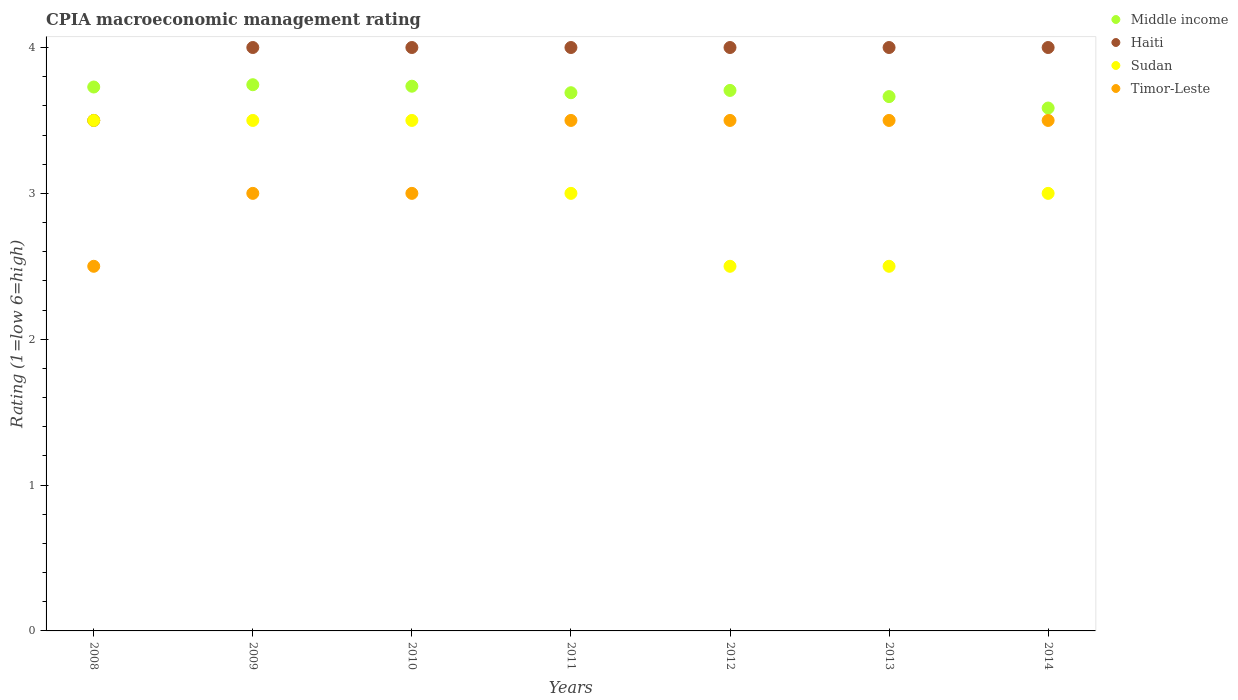How many different coloured dotlines are there?
Your answer should be very brief. 4. Across all years, what is the minimum CPIA rating in Middle income?
Keep it short and to the point. 3.59. In which year was the CPIA rating in Middle income minimum?
Your response must be concise. 2014. What is the total CPIA rating in Middle income in the graph?
Ensure brevity in your answer.  25.85. What is the difference between the CPIA rating in Sudan in 2013 and the CPIA rating in Timor-Leste in 2008?
Give a very brief answer. 0. What is the average CPIA rating in Haiti per year?
Your response must be concise. 3.93. In the year 2011, what is the difference between the CPIA rating in Middle income and CPIA rating in Haiti?
Your answer should be compact. -0.31. In how many years, is the CPIA rating in Sudan greater than 3.6?
Offer a terse response. 0. Is the CPIA rating in Sudan in 2009 less than that in 2010?
Your answer should be compact. No. What is the difference between the highest and the second highest CPIA rating in Sudan?
Offer a very short reply. 0. What is the difference between the highest and the lowest CPIA rating in Middle income?
Your answer should be very brief. 0.16. Is it the case that in every year, the sum of the CPIA rating in Haiti and CPIA rating in Timor-Leste  is greater than the sum of CPIA rating in Sudan and CPIA rating in Middle income?
Keep it short and to the point. No. Is it the case that in every year, the sum of the CPIA rating in Middle income and CPIA rating in Haiti  is greater than the CPIA rating in Timor-Leste?
Offer a terse response. Yes. Does the CPIA rating in Haiti monotonically increase over the years?
Provide a short and direct response. No. Is the CPIA rating in Timor-Leste strictly greater than the CPIA rating in Sudan over the years?
Keep it short and to the point. No. Is the CPIA rating in Sudan strictly less than the CPIA rating in Timor-Leste over the years?
Offer a terse response. No. How many dotlines are there?
Your answer should be very brief. 4. Are the values on the major ticks of Y-axis written in scientific E-notation?
Give a very brief answer. No. What is the title of the graph?
Your answer should be very brief. CPIA macroeconomic management rating. What is the label or title of the X-axis?
Provide a short and direct response. Years. What is the Rating (1=low 6=high) in Middle income in 2008?
Keep it short and to the point. 3.73. What is the Rating (1=low 6=high) of Haiti in 2008?
Give a very brief answer. 3.5. What is the Rating (1=low 6=high) of Sudan in 2008?
Keep it short and to the point. 3.5. What is the Rating (1=low 6=high) of Middle income in 2009?
Your answer should be very brief. 3.74. What is the Rating (1=low 6=high) in Haiti in 2009?
Your answer should be compact. 4. What is the Rating (1=low 6=high) of Timor-Leste in 2009?
Offer a very short reply. 3. What is the Rating (1=low 6=high) in Middle income in 2010?
Offer a terse response. 3.73. What is the Rating (1=low 6=high) of Middle income in 2011?
Keep it short and to the point. 3.69. What is the Rating (1=low 6=high) in Timor-Leste in 2011?
Make the answer very short. 3.5. What is the Rating (1=low 6=high) in Middle income in 2012?
Give a very brief answer. 3.71. What is the Rating (1=low 6=high) of Haiti in 2012?
Ensure brevity in your answer.  4. What is the Rating (1=low 6=high) of Sudan in 2012?
Keep it short and to the point. 2.5. What is the Rating (1=low 6=high) in Middle income in 2013?
Ensure brevity in your answer.  3.66. What is the Rating (1=low 6=high) in Haiti in 2013?
Offer a very short reply. 4. What is the Rating (1=low 6=high) in Sudan in 2013?
Provide a succinct answer. 2.5. What is the Rating (1=low 6=high) in Timor-Leste in 2013?
Give a very brief answer. 3.5. What is the Rating (1=low 6=high) of Middle income in 2014?
Provide a succinct answer. 3.59. What is the Rating (1=low 6=high) in Haiti in 2014?
Offer a terse response. 4. What is the Rating (1=low 6=high) of Sudan in 2014?
Offer a terse response. 3. What is the Rating (1=low 6=high) in Timor-Leste in 2014?
Your answer should be compact. 3.5. Across all years, what is the maximum Rating (1=low 6=high) in Middle income?
Give a very brief answer. 3.74. Across all years, what is the minimum Rating (1=low 6=high) in Middle income?
Offer a very short reply. 3.59. Across all years, what is the minimum Rating (1=low 6=high) of Haiti?
Offer a terse response. 3.5. Across all years, what is the minimum Rating (1=low 6=high) in Sudan?
Provide a short and direct response. 2.5. What is the total Rating (1=low 6=high) in Middle income in the graph?
Offer a terse response. 25.85. What is the total Rating (1=low 6=high) in Sudan in the graph?
Make the answer very short. 21.5. What is the total Rating (1=low 6=high) of Timor-Leste in the graph?
Make the answer very short. 22.5. What is the difference between the Rating (1=low 6=high) in Middle income in 2008 and that in 2009?
Give a very brief answer. -0.02. What is the difference between the Rating (1=low 6=high) in Sudan in 2008 and that in 2009?
Your answer should be compact. 0. What is the difference between the Rating (1=low 6=high) of Timor-Leste in 2008 and that in 2009?
Ensure brevity in your answer.  -0.5. What is the difference between the Rating (1=low 6=high) of Middle income in 2008 and that in 2010?
Keep it short and to the point. -0.01. What is the difference between the Rating (1=low 6=high) of Sudan in 2008 and that in 2010?
Offer a very short reply. 0. What is the difference between the Rating (1=low 6=high) of Timor-Leste in 2008 and that in 2010?
Give a very brief answer. -0.5. What is the difference between the Rating (1=low 6=high) of Middle income in 2008 and that in 2011?
Keep it short and to the point. 0.04. What is the difference between the Rating (1=low 6=high) in Haiti in 2008 and that in 2011?
Give a very brief answer. -0.5. What is the difference between the Rating (1=low 6=high) in Sudan in 2008 and that in 2011?
Make the answer very short. 0.5. What is the difference between the Rating (1=low 6=high) of Middle income in 2008 and that in 2012?
Give a very brief answer. 0.02. What is the difference between the Rating (1=low 6=high) of Haiti in 2008 and that in 2012?
Provide a short and direct response. -0.5. What is the difference between the Rating (1=low 6=high) of Timor-Leste in 2008 and that in 2012?
Provide a succinct answer. -1. What is the difference between the Rating (1=low 6=high) of Middle income in 2008 and that in 2013?
Offer a very short reply. 0.07. What is the difference between the Rating (1=low 6=high) in Middle income in 2008 and that in 2014?
Provide a succinct answer. 0.14. What is the difference between the Rating (1=low 6=high) of Timor-Leste in 2008 and that in 2014?
Provide a short and direct response. -1. What is the difference between the Rating (1=low 6=high) in Middle income in 2009 and that in 2010?
Keep it short and to the point. 0.01. What is the difference between the Rating (1=low 6=high) in Sudan in 2009 and that in 2010?
Offer a very short reply. 0. What is the difference between the Rating (1=low 6=high) in Middle income in 2009 and that in 2011?
Your answer should be compact. 0.05. What is the difference between the Rating (1=low 6=high) of Middle income in 2009 and that in 2012?
Your answer should be compact. 0.04. What is the difference between the Rating (1=low 6=high) in Middle income in 2009 and that in 2013?
Make the answer very short. 0.08. What is the difference between the Rating (1=low 6=high) in Haiti in 2009 and that in 2013?
Give a very brief answer. 0. What is the difference between the Rating (1=low 6=high) of Timor-Leste in 2009 and that in 2013?
Make the answer very short. -0.5. What is the difference between the Rating (1=low 6=high) of Middle income in 2009 and that in 2014?
Your response must be concise. 0.16. What is the difference between the Rating (1=low 6=high) in Haiti in 2009 and that in 2014?
Make the answer very short. 0. What is the difference between the Rating (1=low 6=high) of Sudan in 2009 and that in 2014?
Provide a short and direct response. 0.5. What is the difference between the Rating (1=low 6=high) in Timor-Leste in 2009 and that in 2014?
Your answer should be compact. -0.5. What is the difference between the Rating (1=low 6=high) in Middle income in 2010 and that in 2011?
Your answer should be compact. 0.04. What is the difference between the Rating (1=low 6=high) in Timor-Leste in 2010 and that in 2011?
Provide a short and direct response. -0.5. What is the difference between the Rating (1=low 6=high) of Middle income in 2010 and that in 2012?
Give a very brief answer. 0.03. What is the difference between the Rating (1=low 6=high) of Haiti in 2010 and that in 2012?
Offer a terse response. 0. What is the difference between the Rating (1=low 6=high) of Sudan in 2010 and that in 2012?
Provide a succinct answer. 1. What is the difference between the Rating (1=low 6=high) in Timor-Leste in 2010 and that in 2012?
Provide a short and direct response. -0.5. What is the difference between the Rating (1=low 6=high) of Middle income in 2010 and that in 2013?
Give a very brief answer. 0.07. What is the difference between the Rating (1=low 6=high) in Sudan in 2010 and that in 2013?
Provide a short and direct response. 1. What is the difference between the Rating (1=low 6=high) of Middle income in 2010 and that in 2014?
Make the answer very short. 0.15. What is the difference between the Rating (1=low 6=high) in Sudan in 2010 and that in 2014?
Offer a terse response. 0.5. What is the difference between the Rating (1=low 6=high) of Timor-Leste in 2010 and that in 2014?
Offer a very short reply. -0.5. What is the difference between the Rating (1=low 6=high) of Middle income in 2011 and that in 2012?
Your answer should be very brief. -0.02. What is the difference between the Rating (1=low 6=high) of Haiti in 2011 and that in 2012?
Make the answer very short. 0. What is the difference between the Rating (1=low 6=high) in Middle income in 2011 and that in 2013?
Keep it short and to the point. 0.03. What is the difference between the Rating (1=low 6=high) in Sudan in 2011 and that in 2013?
Keep it short and to the point. 0.5. What is the difference between the Rating (1=low 6=high) of Middle income in 2011 and that in 2014?
Offer a terse response. 0.1. What is the difference between the Rating (1=low 6=high) of Haiti in 2011 and that in 2014?
Your answer should be compact. 0. What is the difference between the Rating (1=low 6=high) in Sudan in 2011 and that in 2014?
Give a very brief answer. 0. What is the difference between the Rating (1=low 6=high) in Timor-Leste in 2011 and that in 2014?
Provide a succinct answer. 0. What is the difference between the Rating (1=low 6=high) in Middle income in 2012 and that in 2013?
Give a very brief answer. 0.04. What is the difference between the Rating (1=low 6=high) of Sudan in 2012 and that in 2013?
Offer a very short reply. 0. What is the difference between the Rating (1=low 6=high) in Timor-Leste in 2012 and that in 2013?
Offer a terse response. 0. What is the difference between the Rating (1=low 6=high) in Middle income in 2012 and that in 2014?
Give a very brief answer. 0.12. What is the difference between the Rating (1=low 6=high) of Haiti in 2012 and that in 2014?
Keep it short and to the point. 0. What is the difference between the Rating (1=low 6=high) in Sudan in 2012 and that in 2014?
Keep it short and to the point. -0.5. What is the difference between the Rating (1=low 6=high) of Middle income in 2013 and that in 2014?
Your answer should be compact. 0.08. What is the difference between the Rating (1=low 6=high) in Haiti in 2013 and that in 2014?
Your answer should be very brief. 0. What is the difference between the Rating (1=low 6=high) in Sudan in 2013 and that in 2014?
Offer a very short reply. -0.5. What is the difference between the Rating (1=low 6=high) in Timor-Leste in 2013 and that in 2014?
Your answer should be compact. 0. What is the difference between the Rating (1=low 6=high) of Middle income in 2008 and the Rating (1=low 6=high) of Haiti in 2009?
Provide a short and direct response. -0.27. What is the difference between the Rating (1=low 6=high) in Middle income in 2008 and the Rating (1=low 6=high) in Sudan in 2009?
Your response must be concise. 0.23. What is the difference between the Rating (1=low 6=high) of Middle income in 2008 and the Rating (1=low 6=high) of Timor-Leste in 2009?
Ensure brevity in your answer.  0.73. What is the difference between the Rating (1=low 6=high) in Haiti in 2008 and the Rating (1=low 6=high) in Sudan in 2009?
Offer a terse response. 0. What is the difference between the Rating (1=low 6=high) in Haiti in 2008 and the Rating (1=low 6=high) in Timor-Leste in 2009?
Keep it short and to the point. 0.5. What is the difference between the Rating (1=low 6=high) in Sudan in 2008 and the Rating (1=low 6=high) in Timor-Leste in 2009?
Make the answer very short. 0.5. What is the difference between the Rating (1=low 6=high) in Middle income in 2008 and the Rating (1=low 6=high) in Haiti in 2010?
Ensure brevity in your answer.  -0.27. What is the difference between the Rating (1=low 6=high) in Middle income in 2008 and the Rating (1=low 6=high) in Sudan in 2010?
Keep it short and to the point. 0.23. What is the difference between the Rating (1=low 6=high) in Middle income in 2008 and the Rating (1=low 6=high) in Timor-Leste in 2010?
Offer a very short reply. 0.73. What is the difference between the Rating (1=low 6=high) in Haiti in 2008 and the Rating (1=low 6=high) in Timor-Leste in 2010?
Make the answer very short. 0.5. What is the difference between the Rating (1=low 6=high) of Middle income in 2008 and the Rating (1=low 6=high) of Haiti in 2011?
Offer a very short reply. -0.27. What is the difference between the Rating (1=low 6=high) of Middle income in 2008 and the Rating (1=low 6=high) of Sudan in 2011?
Make the answer very short. 0.73. What is the difference between the Rating (1=low 6=high) in Middle income in 2008 and the Rating (1=low 6=high) in Timor-Leste in 2011?
Provide a short and direct response. 0.23. What is the difference between the Rating (1=low 6=high) of Haiti in 2008 and the Rating (1=low 6=high) of Timor-Leste in 2011?
Offer a very short reply. 0. What is the difference between the Rating (1=low 6=high) in Sudan in 2008 and the Rating (1=low 6=high) in Timor-Leste in 2011?
Offer a terse response. 0. What is the difference between the Rating (1=low 6=high) in Middle income in 2008 and the Rating (1=low 6=high) in Haiti in 2012?
Your answer should be very brief. -0.27. What is the difference between the Rating (1=low 6=high) in Middle income in 2008 and the Rating (1=low 6=high) in Sudan in 2012?
Give a very brief answer. 1.23. What is the difference between the Rating (1=low 6=high) of Middle income in 2008 and the Rating (1=low 6=high) of Timor-Leste in 2012?
Your answer should be very brief. 0.23. What is the difference between the Rating (1=low 6=high) in Haiti in 2008 and the Rating (1=low 6=high) in Sudan in 2012?
Provide a succinct answer. 1. What is the difference between the Rating (1=low 6=high) in Sudan in 2008 and the Rating (1=low 6=high) in Timor-Leste in 2012?
Make the answer very short. 0. What is the difference between the Rating (1=low 6=high) of Middle income in 2008 and the Rating (1=low 6=high) of Haiti in 2013?
Make the answer very short. -0.27. What is the difference between the Rating (1=low 6=high) in Middle income in 2008 and the Rating (1=low 6=high) in Sudan in 2013?
Your response must be concise. 1.23. What is the difference between the Rating (1=low 6=high) in Middle income in 2008 and the Rating (1=low 6=high) in Timor-Leste in 2013?
Offer a terse response. 0.23. What is the difference between the Rating (1=low 6=high) of Haiti in 2008 and the Rating (1=low 6=high) of Sudan in 2013?
Provide a short and direct response. 1. What is the difference between the Rating (1=low 6=high) in Haiti in 2008 and the Rating (1=low 6=high) in Timor-Leste in 2013?
Provide a succinct answer. 0. What is the difference between the Rating (1=low 6=high) of Middle income in 2008 and the Rating (1=low 6=high) of Haiti in 2014?
Ensure brevity in your answer.  -0.27. What is the difference between the Rating (1=low 6=high) of Middle income in 2008 and the Rating (1=low 6=high) of Sudan in 2014?
Your response must be concise. 0.73. What is the difference between the Rating (1=low 6=high) in Middle income in 2008 and the Rating (1=low 6=high) in Timor-Leste in 2014?
Offer a terse response. 0.23. What is the difference between the Rating (1=low 6=high) in Haiti in 2008 and the Rating (1=low 6=high) in Sudan in 2014?
Provide a short and direct response. 0.5. What is the difference between the Rating (1=low 6=high) in Haiti in 2008 and the Rating (1=low 6=high) in Timor-Leste in 2014?
Give a very brief answer. 0. What is the difference between the Rating (1=low 6=high) in Sudan in 2008 and the Rating (1=low 6=high) in Timor-Leste in 2014?
Keep it short and to the point. 0. What is the difference between the Rating (1=low 6=high) in Middle income in 2009 and the Rating (1=low 6=high) in Haiti in 2010?
Make the answer very short. -0.26. What is the difference between the Rating (1=low 6=high) in Middle income in 2009 and the Rating (1=low 6=high) in Sudan in 2010?
Make the answer very short. 0.24. What is the difference between the Rating (1=low 6=high) in Middle income in 2009 and the Rating (1=low 6=high) in Timor-Leste in 2010?
Offer a terse response. 0.74. What is the difference between the Rating (1=low 6=high) in Haiti in 2009 and the Rating (1=low 6=high) in Sudan in 2010?
Ensure brevity in your answer.  0.5. What is the difference between the Rating (1=low 6=high) of Haiti in 2009 and the Rating (1=low 6=high) of Timor-Leste in 2010?
Provide a short and direct response. 1. What is the difference between the Rating (1=low 6=high) in Sudan in 2009 and the Rating (1=low 6=high) in Timor-Leste in 2010?
Provide a succinct answer. 0.5. What is the difference between the Rating (1=low 6=high) of Middle income in 2009 and the Rating (1=low 6=high) of Haiti in 2011?
Make the answer very short. -0.26. What is the difference between the Rating (1=low 6=high) of Middle income in 2009 and the Rating (1=low 6=high) of Sudan in 2011?
Ensure brevity in your answer.  0.74. What is the difference between the Rating (1=low 6=high) of Middle income in 2009 and the Rating (1=low 6=high) of Timor-Leste in 2011?
Provide a succinct answer. 0.24. What is the difference between the Rating (1=low 6=high) of Middle income in 2009 and the Rating (1=low 6=high) of Haiti in 2012?
Provide a succinct answer. -0.26. What is the difference between the Rating (1=low 6=high) of Middle income in 2009 and the Rating (1=low 6=high) of Sudan in 2012?
Ensure brevity in your answer.  1.24. What is the difference between the Rating (1=low 6=high) of Middle income in 2009 and the Rating (1=low 6=high) of Timor-Leste in 2012?
Make the answer very short. 0.24. What is the difference between the Rating (1=low 6=high) of Middle income in 2009 and the Rating (1=low 6=high) of Haiti in 2013?
Offer a terse response. -0.26. What is the difference between the Rating (1=low 6=high) of Middle income in 2009 and the Rating (1=low 6=high) of Sudan in 2013?
Ensure brevity in your answer.  1.24. What is the difference between the Rating (1=low 6=high) in Middle income in 2009 and the Rating (1=low 6=high) in Timor-Leste in 2013?
Provide a short and direct response. 0.24. What is the difference between the Rating (1=low 6=high) in Haiti in 2009 and the Rating (1=low 6=high) in Timor-Leste in 2013?
Ensure brevity in your answer.  0.5. What is the difference between the Rating (1=low 6=high) of Sudan in 2009 and the Rating (1=low 6=high) of Timor-Leste in 2013?
Your answer should be very brief. 0. What is the difference between the Rating (1=low 6=high) of Middle income in 2009 and the Rating (1=low 6=high) of Haiti in 2014?
Keep it short and to the point. -0.26. What is the difference between the Rating (1=low 6=high) of Middle income in 2009 and the Rating (1=low 6=high) of Sudan in 2014?
Keep it short and to the point. 0.74. What is the difference between the Rating (1=low 6=high) in Middle income in 2009 and the Rating (1=low 6=high) in Timor-Leste in 2014?
Your response must be concise. 0.24. What is the difference between the Rating (1=low 6=high) of Haiti in 2009 and the Rating (1=low 6=high) of Sudan in 2014?
Offer a very short reply. 1. What is the difference between the Rating (1=low 6=high) in Sudan in 2009 and the Rating (1=low 6=high) in Timor-Leste in 2014?
Offer a terse response. 0. What is the difference between the Rating (1=low 6=high) in Middle income in 2010 and the Rating (1=low 6=high) in Haiti in 2011?
Provide a short and direct response. -0.27. What is the difference between the Rating (1=low 6=high) of Middle income in 2010 and the Rating (1=low 6=high) of Sudan in 2011?
Offer a terse response. 0.73. What is the difference between the Rating (1=low 6=high) of Middle income in 2010 and the Rating (1=low 6=high) of Timor-Leste in 2011?
Your answer should be very brief. 0.23. What is the difference between the Rating (1=low 6=high) of Haiti in 2010 and the Rating (1=low 6=high) of Timor-Leste in 2011?
Provide a short and direct response. 0.5. What is the difference between the Rating (1=low 6=high) of Middle income in 2010 and the Rating (1=low 6=high) of Haiti in 2012?
Make the answer very short. -0.27. What is the difference between the Rating (1=low 6=high) in Middle income in 2010 and the Rating (1=low 6=high) in Sudan in 2012?
Provide a succinct answer. 1.23. What is the difference between the Rating (1=low 6=high) in Middle income in 2010 and the Rating (1=low 6=high) in Timor-Leste in 2012?
Your answer should be very brief. 0.23. What is the difference between the Rating (1=low 6=high) of Haiti in 2010 and the Rating (1=low 6=high) of Sudan in 2012?
Make the answer very short. 1.5. What is the difference between the Rating (1=low 6=high) in Sudan in 2010 and the Rating (1=low 6=high) in Timor-Leste in 2012?
Your response must be concise. 0. What is the difference between the Rating (1=low 6=high) of Middle income in 2010 and the Rating (1=low 6=high) of Haiti in 2013?
Offer a terse response. -0.27. What is the difference between the Rating (1=low 6=high) of Middle income in 2010 and the Rating (1=low 6=high) of Sudan in 2013?
Ensure brevity in your answer.  1.23. What is the difference between the Rating (1=low 6=high) of Middle income in 2010 and the Rating (1=low 6=high) of Timor-Leste in 2013?
Provide a short and direct response. 0.23. What is the difference between the Rating (1=low 6=high) of Haiti in 2010 and the Rating (1=low 6=high) of Timor-Leste in 2013?
Your answer should be compact. 0.5. What is the difference between the Rating (1=low 6=high) in Middle income in 2010 and the Rating (1=low 6=high) in Haiti in 2014?
Provide a succinct answer. -0.27. What is the difference between the Rating (1=low 6=high) in Middle income in 2010 and the Rating (1=low 6=high) in Sudan in 2014?
Ensure brevity in your answer.  0.73. What is the difference between the Rating (1=low 6=high) of Middle income in 2010 and the Rating (1=low 6=high) of Timor-Leste in 2014?
Provide a succinct answer. 0.23. What is the difference between the Rating (1=low 6=high) of Haiti in 2010 and the Rating (1=low 6=high) of Timor-Leste in 2014?
Provide a succinct answer. 0.5. What is the difference between the Rating (1=low 6=high) of Sudan in 2010 and the Rating (1=low 6=high) of Timor-Leste in 2014?
Offer a very short reply. 0. What is the difference between the Rating (1=low 6=high) of Middle income in 2011 and the Rating (1=low 6=high) of Haiti in 2012?
Give a very brief answer. -0.31. What is the difference between the Rating (1=low 6=high) of Middle income in 2011 and the Rating (1=low 6=high) of Sudan in 2012?
Your answer should be compact. 1.19. What is the difference between the Rating (1=low 6=high) in Middle income in 2011 and the Rating (1=low 6=high) in Timor-Leste in 2012?
Your response must be concise. 0.19. What is the difference between the Rating (1=low 6=high) of Haiti in 2011 and the Rating (1=low 6=high) of Sudan in 2012?
Your response must be concise. 1.5. What is the difference between the Rating (1=low 6=high) in Middle income in 2011 and the Rating (1=low 6=high) in Haiti in 2013?
Provide a short and direct response. -0.31. What is the difference between the Rating (1=low 6=high) in Middle income in 2011 and the Rating (1=low 6=high) in Sudan in 2013?
Offer a terse response. 1.19. What is the difference between the Rating (1=low 6=high) in Middle income in 2011 and the Rating (1=low 6=high) in Timor-Leste in 2013?
Keep it short and to the point. 0.19. What is the difference between the Rating (1=low 6=high) in Middle income in 2011 and the Rating (1=low 6=high) in Haiti in 2014?
Keep it short and to the point. -0.31. What is the difference between the Rating (1=low 6=high) in Middle income in 2011 and the Rating (1=low 6=high) in Sudan in 2014?
Ensure brevity in your answer.  0.69. What is the difference between the Rating (1=low 6=high) of Middle income in 2011 and the Rating (1=low 6=high) of Timor-Leste in 2014?
Keep it short and to the point. 0.19. What is the difference between the Rating (1=low 6=high) of Haiti in 2011 and the Rating (1=low 6=high) of Sudan in 2014?
Your answer should be compact. 1. What is the difference between the Rating (1=low 6=high) in Haiti in 2011 and the Rating (1=low 6=high) in Timor-Leste in 2014?
Give a very brief answer. 0.5. What is the difference between the Rating (1=low 6=high) of Sudan in 2011 and the Rating (1=low 6=high) of Timor-Leste in 2014?
Ensure brevity in your answer.  -0.5. What is the difference between the Rating (1=low 6=high) of Middle income in 2012 and the Rating (1=low 6=high) of Haiti in 2013?
Provide a succinct answer. -0.29. What is the difference between the Rating (1=low 6=high) of Middle income in 2012 and the Rating (1=low 6=high) of Sudan in 2013?
Provide a short and direct response. 1.21. What is the difference between the Rating (1=low 6=high) of Middle income in 2012 and the Rating (1=low 6=high) of Timor-Leste in 2013?
Your answer should be compact. 0.21. What is the difference between the Rating (1=low 6=high) in Middle income in 2012 and the Rating (1=low 6=high) in Haiti in 2014?
Your answer should be very brief. -0.29. What is the difference between the Rating (1=low 6=high) in Middle income in 2012 and the Rating (1=low 6=high) in Sudan in 2014?
Your response must be concise. 0.71. What is the difference between the Rating (1=low 6=high) of Middle income in 2012 and the Rating (1=low 6=high) of Timor-Leste in 2014?
Keep it short and to the point. 0.21. What is the difference between the Rating (1=low 6=high) of Haiti in 2012 and the Rating (1=low 6=high) of Timor-Leste in 2014?
Your answer should be compact. 0.5. What is the difference between the Rating (1=low 6=high) in Sudan in 2012 and the Rating (1=low 6=high) in Timor-Leste in 2014?
Ensure brevity in your answer.  -1. What is the difference between the Rating (1=low 6=high) of Middle income in 2013 and the Rating (1=low 6=high) of Haiti in 2014?
Provide a short and direct response. -0.34. What is the difference between the Rating (1=low 6=high) in Middle income in 2013 and the Rating (1=low 6=high) in Sudan in 2014?
Your answer should be very brief. 0.66. What is the difference between the Rating (1=low 6=high) in Middle income in 2013 and the Rating (1=low 6=high) in Timor-Leste in 2014?
Give a very brief answer. 0.16. What is the difference between the Rating (1=low 6=high) of Haiti in 2013 and the Rating (1=low 6=high) of Sudan in 2014?
Your answer should be compact. 1. What is the average Rating (1=low 6=high) of Middle income per year?
Your answer should be compact. 3.69. What is the average Rating (1=low 6=high) of Haiti per year?
Keep it short and to the point. 3.93. What is the average Rating (1=low 6=high) in Sudan per year?
Ensure brevity in your answer.  3.07. What is the average Rating (1=low 6=high) in Timor-Leste per year?
Offer a very short reply. 3.21. In the year 2008, what is the difference between the Rating (1=low 6=high) of Middle income and Rating (1=low 6=high) of Haiti?
Ensure brevity in your answer.  0.23. In the year 2008, what is the difference between the Rating (1=low 6=high) in Middle income and Rating (1=low 6=high) in Sudan?
Make the answer very short. 0.23. In the year 2008, what is the difference between the Rating (1=low 6=high) in Middle income and Rating (1=low 6=high) in Timor-Leste?
Provide a short and direct response. 1.23. In the year 2008, what is the difference between the Rating (1=low 6=high) in Haiti and Rating (1=low 6=high) in Sudan?
Your answer should be very brief. 0. In the year 2008, what is the difference between the Rating (1=low 6=high) in Haiti and Rating (1=low 6=high) in Timor-Leste?
Offer a terse response. 1. In the year 2009, what is the difference between the Rating (1=low 6=high) in Middle income and Rating (1=low 6=high) in Haiti?
Ensure brevity in your answer.  -0.26. In the year 2009, what is the difference between the Rating (1=low 6=high) in Middle income and Rating (1=low 6=high) in Sudan?
Ensure brevity in your answer.  0.24. In the year 2009, what is the difference between the Rating (1=low 6=high) of Middle income and Rating (1=low 6=high) of Timor-Leste?
Make the answer very short. 0.74. In the year 2009, what is the difference between the Rating (1=low 6=high) in Haiti and Rating (1=low 6=high) in Timor-Leste?
Your answer should be very brief. 1. In the year 2009, what is the difference between the Rating (1=low 6=high) of Sudan and Rating (1=low 6=high) of Timor-Leste?
Give a very brief answer. 0.5. In the year 2010, what is the difference between the Rating (1=low 6=high) in Middle income and Rating (1=low 6=high) in Haiti?
Offer a very short reply. -0.27. In the year 2010, what is the difference between the Rating (1=low 6=high) of Middle income and Rating (1=low 6=high) of Sudan?
Provide a short and direct response. 0.23. In the year 2010, what is the difference between the Rating (1=low 6=high) in Middle income and Rating (1=low 6=high) in Timor-Leste?
Give a very brief answer. 0.73. In the year 2010, what is the difference between the Rating (1=low 6=high) of Haiti and Rating (1=low 6=high) of Timor-Leste?
Give a very brief answer. 1. In the year 2011, what is the difference between the Rating (1=low 6=high) in Middle income and Rating (1=low 6=high) in Haiti?
Offer a very short reply. -0.31. In the year 2011, what is the difference between the Rating (1=low 6=high) of Middle income and Rating (1=low 6=high) of Sudan?
Provide a short and direct response. 0.69. In the year 2011, what is the difference between the Rating (1=low 6=high) in Middle income and Rating (1=low 6=high) in Timor-Leste?
Ensure brevity in your answer.  0.19. In the year 2011, what is the difference between the Rating (1=low 6=high) of Haiti and Rating (1=low 6=high) of Sudan?
Give a very brief answer. 1. In the year 2012, what is the difference between the Rating (1=low 6=high) in Middle income and Rating (1=low 6=high) in Haiti?
Make the answer very short. -0.29. In the year 2012, what is the difference between the Rating (1=low 6=high) in Middle income and Rating (1=low 6=high) in Sudan?
Offer a very short reply. 1.21. In the year 2012, what is the difference between the Rating (1=low 6=high) of Middle income and Rating (1=low 6=high) of Timor-Leste?
Your answer should be very brief. 0.21. In the year 2012, what is the difference between the Rating (1=low 6=high) in Haiti and Rating (1=low 6=high) in Sudan?
Offer a terse response. 1.5. In the year 2012, what is the difference between the Rating (1=low 6=high) of Haiti and Rating (1=low 6=high) of Timor-Leste?
Offer a very short reply. 0.5. In the year 2013, what is the difference between the Rating (1=low 6=high) of Middle income and Rating (1=low 6=high) of Haiti?
Provide a succinct answer. -0.34. In the year 2013, what is the difference between the Rating (1=low 6=high) in Middle income and Rating (1=low 6=high) in Sudan?
Offer a terse response. 1.16. In the year 2013, what is the difference between the Rating (1=low 6=high) of Middle income and Rating (1=low 6=high) of Timor-Leste?
Make the answer very short. 0.16. In the year 2013, what is the difference between the Rating (1=low 6=high) in Haiti and Rating (1=low 6=high) in Sudan?
Ensure brevity in your answer.  1.5. In the year 2013, what is the difference between the Rating (1=low 6=high) of Haiti and Rating (1=low 6=high) of Timor-Leste?
Make the answer very short. 0.5. In the year 2013, what is the difference between the Rating (1=low 6=high) in Sudan and Rating (1=low 6=high) in Timor-Leste?
Keep it short and to the point. -1. In the year 2014, what is the difference between the Rating (1=low 6=high) of Middle income and Rating (1=low 6=high) of Haiti?
Provide a short and direct response. -0.41. In the year 2014, what is the difference between the Rating (1=low 6=high) in Middle income and Rating (1=low 6=high) in Sudan?
Your answer should be very brief. 0.59. In the year 2014, what is the difference between the Rating (1=low 6=high) of Middle income and Rating (1=low 6=high) of Timor-Leste?
Your answer should be compact. 0.09. In the year 2014, what is the difference between the Rating (1=low 6=high) in Haiti and Rating (1=low 6=high) in Sudan?
Offer a very short reply. 1. In the year 2014, what is the difference between the Rating (1=low 6=high) in Sudan and Rating (1=low 6=high) in Timor-Leste?
Provide a succinct answer. -0.5. What is the ratio of the Rating (1=low 6=high) of Haiti in 2008 to that in 2009?
Offer a very short reply. 0.88. What is the ratio of the Rating (1=low 6=high) in Sudan in 2008 to that in 2009?
Offer a terse response. 1. What is the ratio of the Rating (1=low 6=high) of Timor-Leste in 2008 to that in 2009?
Provide a short and direct response. 0.83. What is the ratio of the Rating (1=low 6=high) of Middle income in 2008 to that in 2010?
Offer a very short reply. 1. What is the ratio of the Rating (1=low 6=high) of Middle income in 2008 to that in 2011?
Offer a terse response. 1.01. What is the ratio of the Rating (1=low 6=high) in Haiti in 2008 to that in 2011?
Your answer should be very brief. 0.88. What is the ratio of the Rating (1=low 6=high) in Sudan in 2008 to that in 2011?
Provide a succinct answer. 1.17. What is the ratio of the Rating (1=low 6=high) of Timor-Leste in 2008 to that in 2011?
Give a very brief answer. 0.71. What is the ratio of the Rating (1=low 6=high) of Middle income in 2008 to that in 2012?
Offer a terse response. 1.01. What is the ratio of the Rating (1=low 6=high) in Sudan in 2008 to that in 2012?
Ensure brevity in your answer.  1.4. What is the ratio of the Rating (1=low 6=high) of Timor-Leste in 2008 to that in 2012?
Keep it short and to the point. 0.71. What is the ratio of the Rating (1=low 6=high) of Middle income in 2008 to that in 2013?
Offer a very short reply. 1.02. What is the ratio of the Rating (1=low 6=high) in Haiti in 2008 to that in 2013?
Give a very brief answer. 0.88. What is the ratio of the Rating (1=low 6=high) in Middle income in 2008 to that in 2014?
Ensure brevity in your answer.  1.04. What is the ratio of the Rating (1=low 6=high) of Haiti in 2009 to that in 2010?
Keep it short and to the point. 1. What is the ratio of the Rating (1=low 6=high) in Middle income in 2009 to that in 2011?
Your response must be concise. 1.01. What is the ratio of the Rating (1=low 6=high) in Sudan in 2009 to that in 2011?
Your answer should be compact. 1.17. What is the ratio of the Rating (1=low 6=high) in Timor-Leste in 2009 to that in 2011?
Your answer should be very brief. 0.86. What is the ratio of the Rating (1=low 6=high) in Middle income in 2009 to that in 2012?
Your answer should be compact. 1.01. What is the ratio of the Rating (1=low 6=high) in Haiti in 2009 to that in 2012?
Keep it short and to the point. 1. What is the ratio of the Rating (1=low 6=high) of Middle income in 2009 to that in 2013?
Provide a short and direct response. 1.02. What is the ratio of the Rating (1=low 6=high) in Middle income in 2009 to that in 2014?
Ensure brevity in your answer.  1.04. What is the ratio of the Rating (1=low 6=high) in Haiti in 2009 to that in 2014?
Offer a terse response. 1. What is the ratio of the Rating (1=low 6=high) in Sudan in 2009 to that in 2014?
Offer a terse response. 1.17. What is the ratio of the Rating (1=low 6=high) in Timor-Leste in 2009 to that in 2014?
Your response must be concise. 0.86. What is the ratio of the Rating (1=low 6=high) of Middle income in 2010 to that in 2011?
Provide a short and direct response. 1.01. What is the ratio of the Rating (1=low 6=high) in Haiti in 2010 to that in 2011?
Keep it short and to the point. 1. What is the ratio of the Rating (1=low 6=high) in Timor-Leste in 2010 to that in 2011?
Provide a succinct answer. 0.86. What is the ratio of the Rating (1=low 6=high) in Sudan in 2010 to that in 2012?
Your response must be concise. 1.4. What is the ratio of the Rating (1=low 6=high) in Timor-Leste in 2010 to that in 2012?
Provide a short and direct response. 0.86. What is the ratio of the Rating (1=low 6=high) in Middle income in 2010 to that in 2013?
Ensure brevity in your answer.  1.02. What is the ratio of the Rating (1=low 6=high) of Haiti in 2010 to that in 2013?
Offer a terse response. 1. What is the ratio of the Rating (1=low 6=high) in Sudan in 2010 to that in 2013?
Offer a very short reply. 1.4. What is the ratio of the Rating (1=low 6=high) of Timor-Leste in 2010 to that in 2013?
Your answer should be very brief. 0.86. What is the ratio of the Rating (1=low 6=high) of Middle income in 2010 to that in 2014?
Provide a short and direct response. 1.04. What is the ratio of the Rating (1=low 6=high) in Timor-Leste in 2010 to that in 2014?
Ensure brevity in your answer.  0.86. What is the ratio of the Rating (1=low 6=high) in Middle income in 2011 to that in 2013?
Your answer should be compact. 1.01. What is the ratio of the Rating (1=low 6=high) in Sudan in 2011 to that in 2013?
Provide a succinct answer. 1.2. What is the ratio of the Rating (1=low 6=high) in Middle income in 2011 to that in 2014?
Your answer should be compact. 1.03. What is the ratio of the Rating (1=low 6=high) in Haiti in 2011 to that in 2014?
Your response must be concise. 1. What is the ratio of the Rating (1=low 6=high) in Sudan in 2011 to that in 2014?
Your response must be concise. 1. What is the ratio of the Rating (1=low 6=high) in Timor-Leste in 2011 to that in 2014?
Your answer should be compact. 1. What is the ratio of the Rating (1=low 6=high) in Middle income in 2012 to that in 2013?
Offer a terse response. 1.01. What is the ratio of the Rating (1=low 6=high) in Haiti in 2012 to that in 2013?
Provide a short and direct response. 1. What is the ratio of the Rating (1=low 6=high) in Sudan in 2012 to that in 2013?
Offer a terse response. 1. What is the ratio of the Rating (1=low 6=high) of Timor-Leste in 2012 to that in 2013?
Provide a succinct answer. 1. What is the ratio of the Rating (1=low 6=high) in Middle income in 2012 to that in 2014?
Give a very brief answer. 1.03. What is the ratio of the Rating (1=low 6=high) of Haiti in 2012 to that in 2014?
Keep it short and to the point. 1. What is the ratio of the Rating (1=low 6=high) in Middle income in 2013 to that in 2014?
Your answer should be compact. 1.02. What is the ratio of the Rating (1=low 6=high) of Sudan in 2013 to that in 2014?
Your answer should be very brief. 0.83. What is the difference between the highest and the second highest Rating (1=low 6=high) in Middle income?
Keep it short and to the point. 0.01. What is the difference between the highest and the second highest Rating (1=low 6=high) in Haiti?
Offer a terse response. 0. What is the difference between the highest and the lowest Rating (1=low 6=high) of Middle income?
Keep it short and to the point. 0.16. 